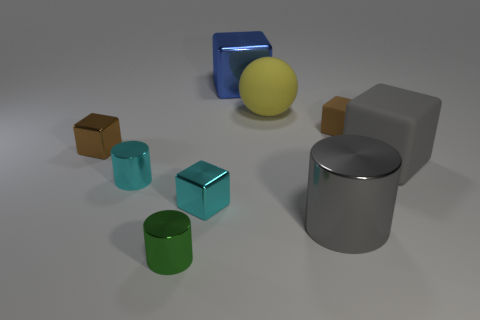The big cylinder in front of the small matte thing is what color?
Provide a succinct answer. Gray. What is the size of the gray object that is made of the same material as the large yellow thing?
Provide a short and direct response. Large. There is a gray object that is the same shape as the green object; what size is it?
Keep it short and to the point. Large. Is there a big ball?
Provide a short and direct response. Yes. How many things are small cylinders in front of the cyan block or big gray objects?
Provide a succinct answer. 3. There is a brown object that is the same size as the brown metal block; what is its material?
Keep it short and to the point. Rubber. What is the color of the big metal thing behind the small brown object that is right of the yellow sphere?
Keep it short and to the point. Blue. There is a yellow thing; how many yellow spheres are behind it?
Keep it short and to the point. 0. The big shiny block has what color?
Provide a short and direct response. Blue. How many big things are green cylinders or metallic cubes?
Your answer should be very brief. 1. 